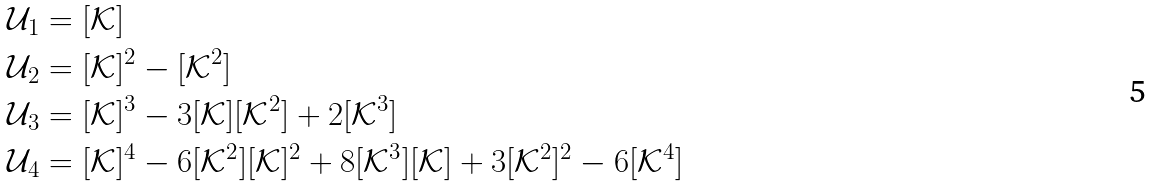Convert formula to latex. <formula><loc_0><loc_0><loc_500><loc_500>& \mathcal { U } _ { 1 } = [ \mathcal { K } ] \\ & \mathcal { U } _ { 2 } = [ \mathcal { K } ] ^ { 2 } - [ \mathcal { K } ^ { 2 } ] \\ & \mathcal { U } _ { 3 } = [ \mathcal { K } ] ^ { 3 } - 3 [ \mathcal { K } ] [ \mathcal { K } ^ { 2 } ] + 2 [ \mathcal { K } ^ { 3 } ] \\ & \mathcal { U } _ { 4 } = [ \mathcal { K } ] ^ { 4 } - 6 [ \mathcal { K } ^ { 2 } ] [ \mathcal { K } ] ^ { 2 } + 8 [ \mathcal { K } ^ { 3 } ] [ \mathcal { K } ] + 3 [ \mathcal { K } ^ { 2 } ] ^ { 2 } - 6 [ \mathcal { K } ^ { 4 } ]</formula> 